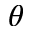<formula> <loc_0><loc_0><loc_500><loc_500>\theta</formula> 